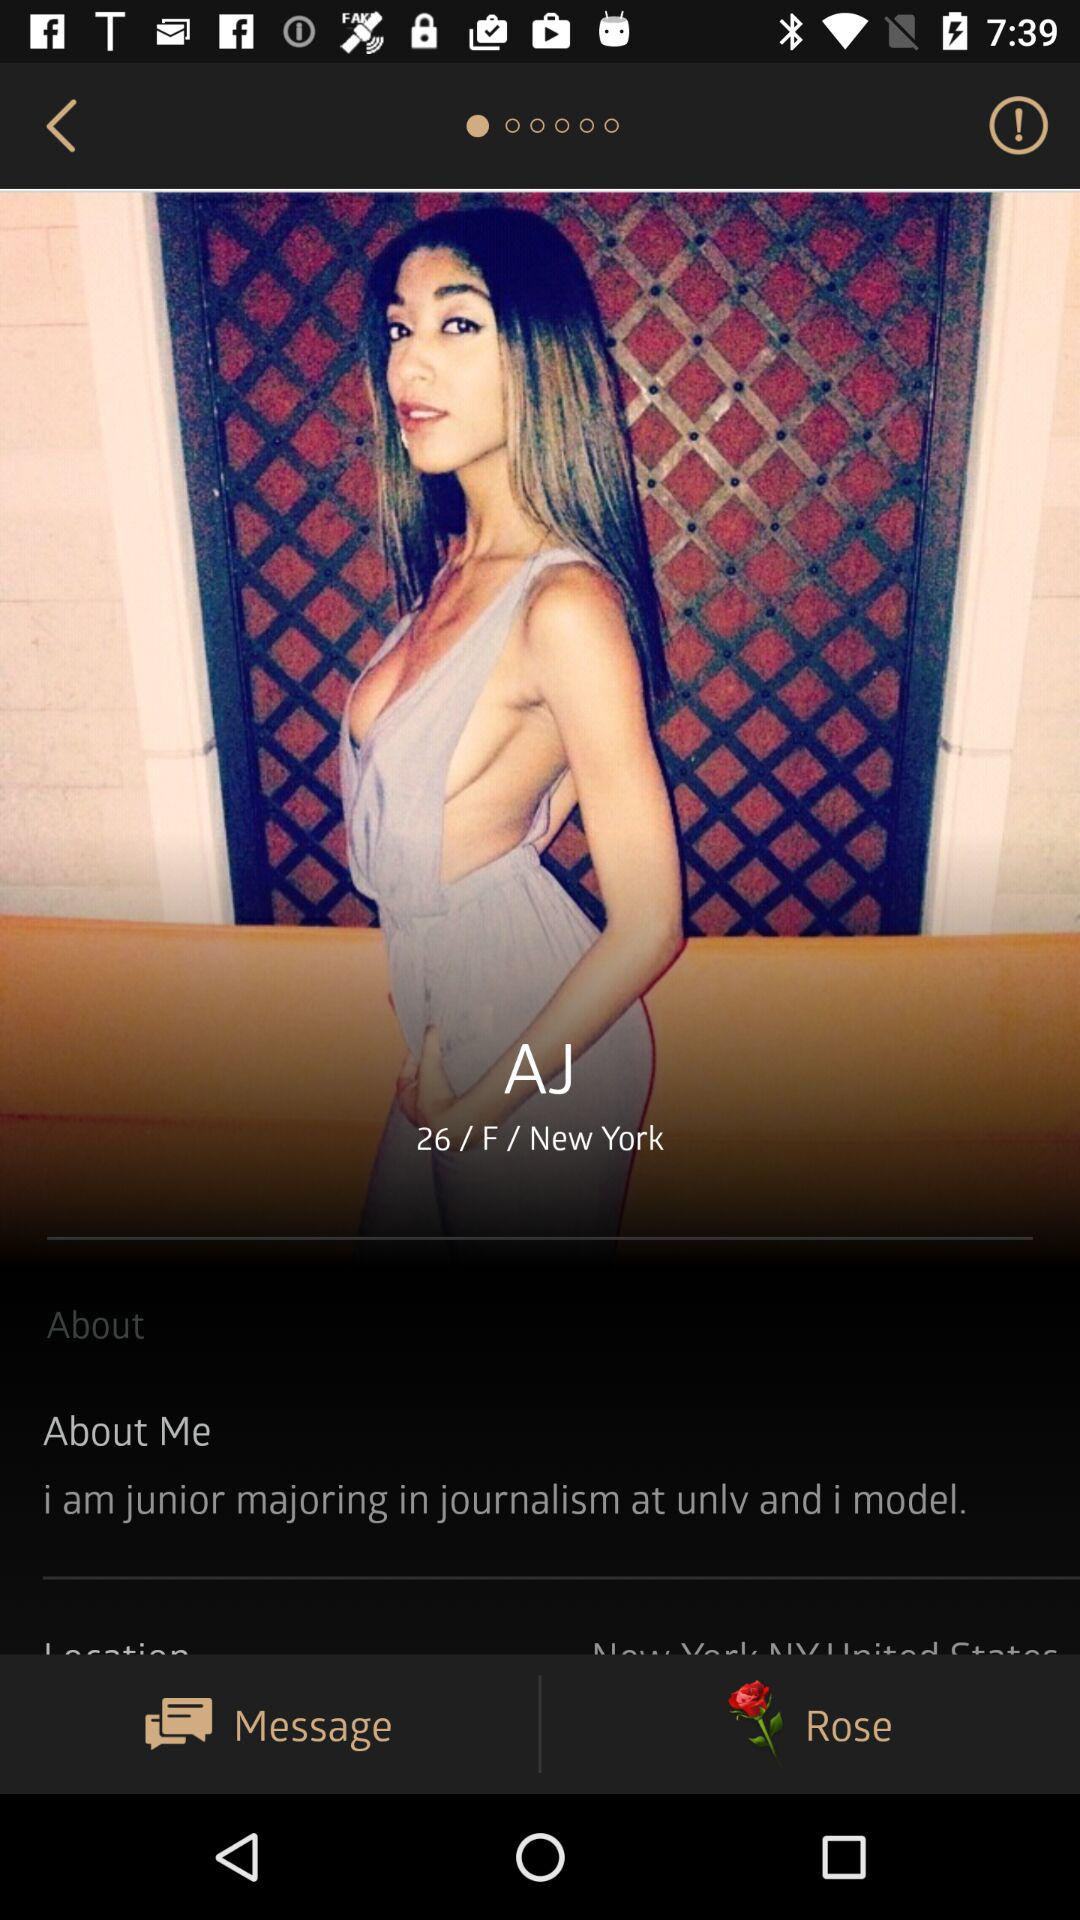What gender has been given? The gender is female. 